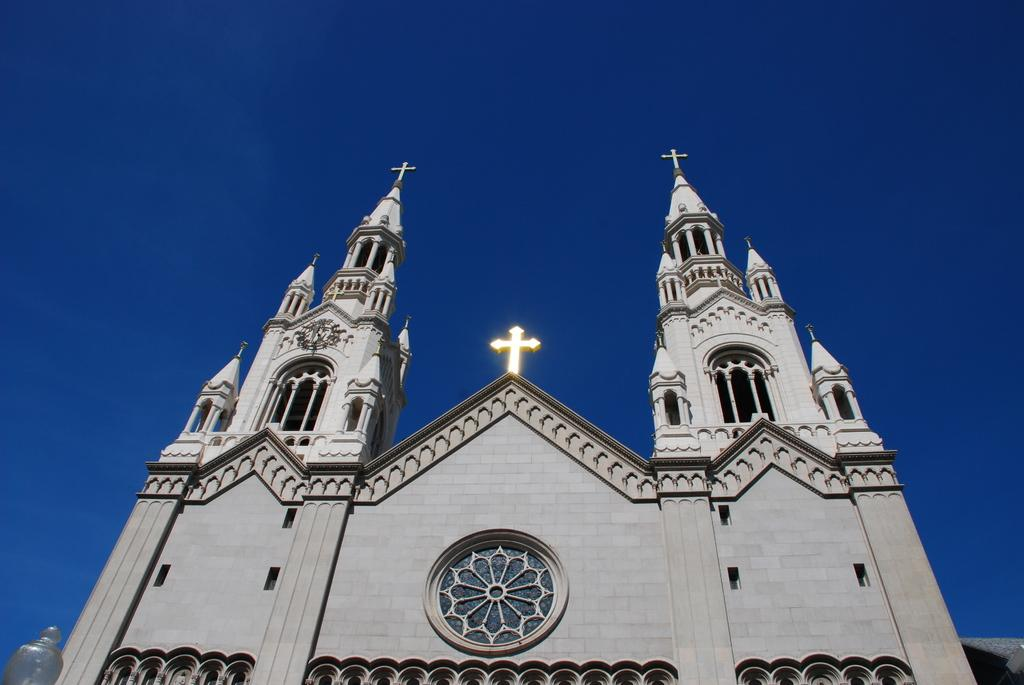What type of building is in the image? There is a church building in the image. Where is the church building located? The church building is situated over a place. What religious symbols can be seen at the top of the church building? Christianity symbols are present at the top of the church building. What is the condition of the sky in the image? The sky is clear in the image. What type of protest is taking place in front of the church building in the image? There is no protest visible in the image; it only shows the church building and the sky. What religious beliefs are being practiced by the people in the image? The image does not show any people, so it is impossible to determine their religious beliefs. 